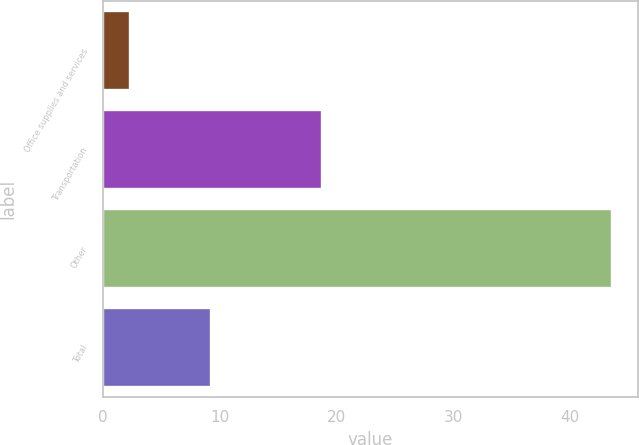Convert chart to OTSL. <chart><loc_0><loc_0><loc_500><loc_500><bar_chart><fcel>Office supplies and services<fcel>Transportation<fcel>Other<fcel>Total<nl><fcel>2.3<fcel>18.8<fcel>43.6<fcel>9.3<nl></chart> 